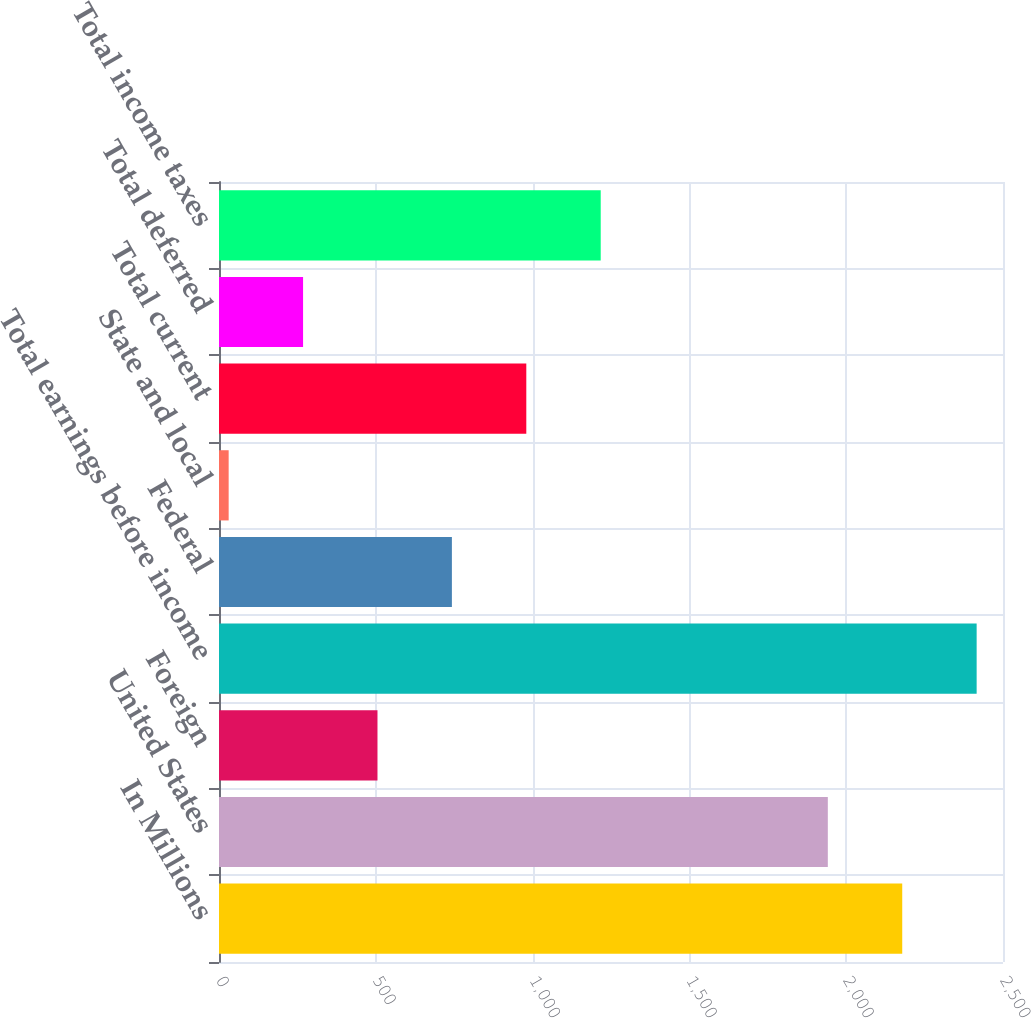Convert chart. <chart><loc_0><loc_0><loc_500><loc_500><bar_chart><fcel>In Millions<fcel>United States<fcel>Foreign<fcel>Total earnings before income<fcel>Federal<fcel>State and local<fcel>Total current<fcel>Total deferred<fcel>Total income taxes<nl><fcel>2178.68<fcel>1941.4<fcel>505.36<fcel>2415.96<fcel>742.64<fcel>30.8<fcel>979.92<fcel>268.08<fcel>1217.2<nl></chart> 